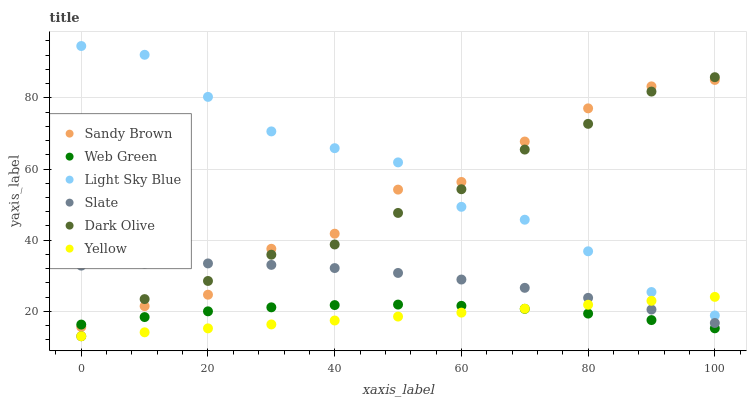Does Yellow have the minimum area under the curve?
Answer yes or no. Yes. Does Light Sky Blue have the maximum area under the curve?
Answer yes or no. Yes. Does Dark Olive have the minimum area under the curve?
Answer yes or no. No. Does Dark Olive have the maximum area under the curve?
Answer yes or no. No. Is Yellow the smoothest?
Answer yes or no. Yes. Is Sandy Brown the roughest?
Answer yes or no. Yes. Is Dark Olive the smoothest?
Answer yes or no. No. Is Dark Olive the roughest?
Answer yes or no. No. Does Dark Olive have the lowest value?
Answer yes or no. Yes. Does Light Sky Blue have the lowest value?
Answer yes or no. No. Does Light Sky Blue have the highest value?
Answer yes or no. Yes. Does Dark Olive have the highest value?
Answer yes or no. No. Is Yellow less than Sandy Brown?
Answer yes or no. Yes. Is Sandy Brown greater than Yellow?
Answer yes or no. Yes. Does Sandy Brown intersect Dark Olive?
Answer yes or no. Yes. Is Sandy Brown less than Dark Olive?
Answer yes or no. No. Is Sandy Brown greater than Dark Olive?
Answer yes or no. No. Does Yellow intersect Sandy Brown?
Answer yes or no. No. 